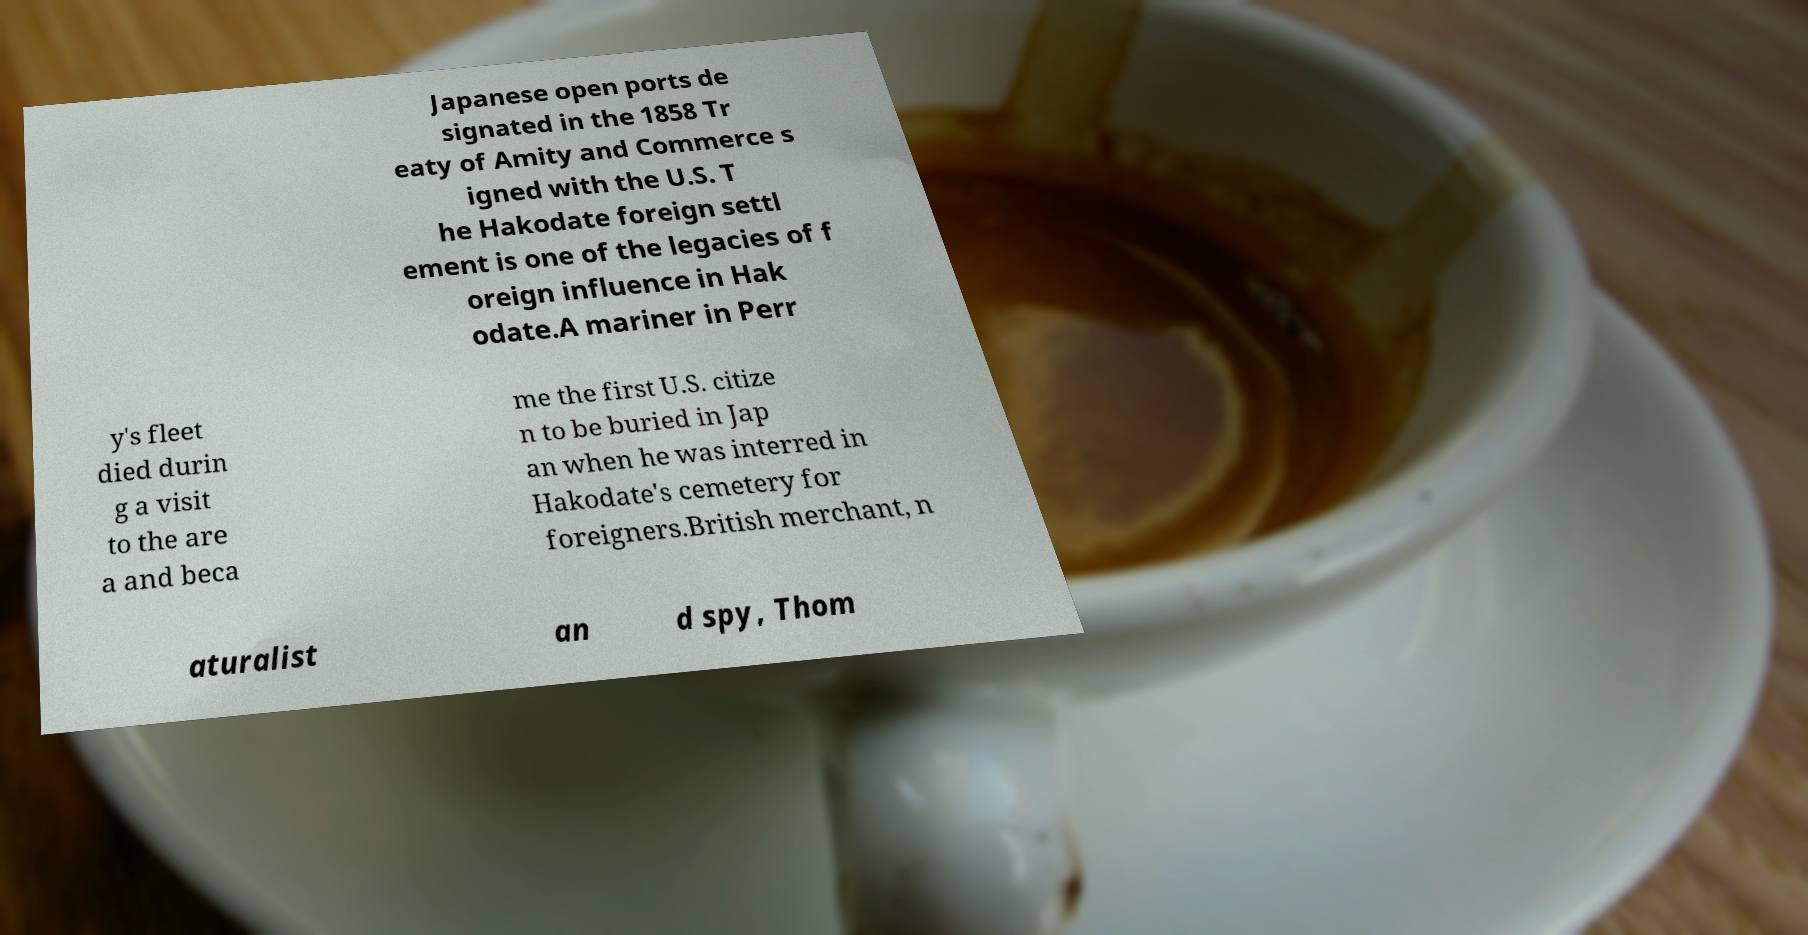Can you accurately transcribe the text from the provided image for me? Japanese open ports de signated in the 1858 Tr eaty of Amity and Commerce s igned with the U.S. T he Hakodate foreign settl ement is one of the legacies of f oreign influence in Hak odate.A mariner in Perr y's fleet died durin g a visit to the are a and beca me the first U.S. citize n to be buried in Jap an when he was interred in Hakodate's cemetery for foreigners.British merchant, n aturalist an d spy, Thom 